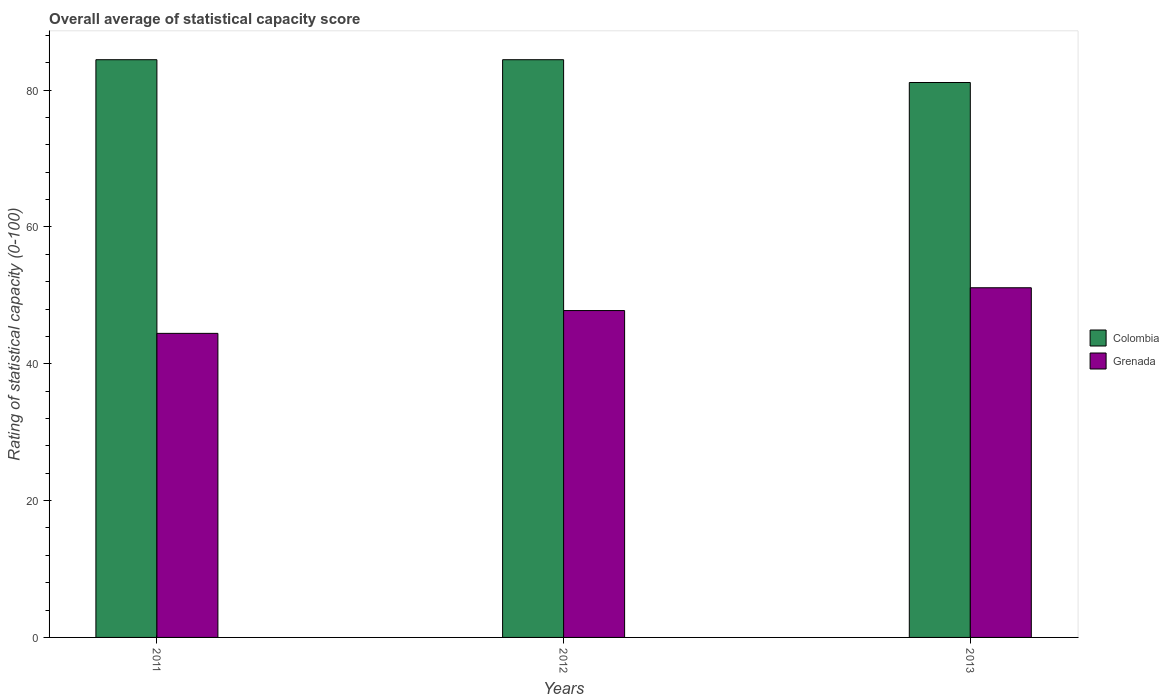How many different coloured bars are there?
Your answer should be very brief. 2. Are the number of bars on each tick of the X-axis equal?
Provide a short and direct response. Yes. How many bars are there on the 3rd tick from the right?
Make the answer very short. 2. What is the label of the 2nd group of bars from the left?
Your answer should be compact. 2012. What is the rating of statistical capacity in Colombia in 2012?
Keep it short and to the point. 84.44. Across all years, what is the maximum rating of statistical capacity in Colombia?
Keep it short and to the point. 84.44. Across all years, what is the minimum rating of statistical capacity in Colombia?
Keep it short and to the point. 81.11. In which year was the rating of statistical capacity in Colombia maximum?
Provide a short and direct response. 2011. In which year was the rating of statistical capacity in Colombia minimum?
Your answer should be compact. 2013. What is the total rating of statistical capacity in Grenada in the graph?
Your response must be concise. 143.33. What is the difference between the rating of statistical capacity in Colombia in 2011 and that in 2013?
Your response must be concise. 3.33. What is the difference between the rating of statistical capacity in Colombia in 2011 and the rating of statistical capacity in Grenada in 2012?
Your answer should be very brief. 36.67. What is the average rating of statistical capacity in Colombia per year?
Give a very brief answer. 83.33. In the year 2012, what is the difference between the rating of statistical capacity in Colombia and rating of statistical capacity in Grenada?
Your answer should be very brief. 36.67. In how many years, is the rating of statistical capacity in Grenada greater than 24?
Keep it short and to the point. 3. Is the difference between the rating of statistical capacity in Colombia in 2012 and 2013 greater than the difference between the rating of statistical capacity in Grenada in 2012 and 2013?
Provide a short and direct response. Yes. What is the difference between the highest and the lowest rating of statistical capacity in Grenada?
Keep it short and to the point. 6.67. What does the 1st bar from the left in 2013 represents?
Provide a short and direct response. Colombia. What does the 1st bar from the right in 2011 represents?
Provide a short and direct response. Grenada. Are all the bars in the graph horizontal?
Give a very brief answer. No. Are the values on the major ticks of Y-axis written in scientific E-notation?
Offer a terse response. No. Does the graph contain any zero values?
Provide a short and direct response. No. Where does the legend appear in the graph?
Your answer should be very brief. Center right. How are the legend labels stacked?
Ensure brevity in your answer.  Vertical. What is the title of the graph?
Keep it short and to the point. Overall average of statistical capacity score. What is the label or title of the Y-axis?
Your answer should be very brief. Rating of statistical capacity (0-100). What is the Rating of statistical capacity (0-100) of Colombia in 2011?
Offer a terse response. 84.44. What is the Rating of statistical capacity (0-100) of Grenada in 2011?
Offer a terse response. 44.44. What is the Rating of statistical capacity (0-100) in Colombia in 2012?
Offer a terse response. 84.44. What is the Rating of statistical capacity (0-100) of Grenada in 2012?
Your answer should be compact. 47.78. What is the Rating of statistical capacity (0-100) of Colombia in 2013?
Provide a succinct answer. 81.11. What is the Rating of statistical capacity (0-100) in Grenada in 2013?
Your response must be concise. 51.11. Across all years, what is the maximum Rating of statistical capacity (0-100) in Colombia?
Give a very brief answer. 84.44. Across all years, what is the maximum Rating of statistical capacity (0-100) in Grenada?
Give a very brief answer. 51.11. Across all years, what is the minimum Rating of statistical capacity (0-100) of Colombia?
Your answer should be very brief. 81.11. Across all years, what is the minimum Rating of statistical capacity (0-100) in Grenada?
Your answer should be compact. 44.44. What is the total Rating of statistical capacity (0-100) of Colombia in the graph?
Keep it short and to the point. 250. What is the total Rating of statistical capacity (0-100) of Grenada in the graph?
Offer a terse response. 143.33. What is the difference between the Rating of statistical capacity (0-100) of Grenada in 2011 and that in 2012?
Offer a terse response. -3.33. What is the difference between the Rating of statistical capacity (0-100) of Grenada in 2011 and that in 2013?
Give a very brief answer. -6.67. What is the difference between the Rating of statistical capacity (0-100) in Colombia in 2012 and that in 2013?
Provide a succinct answer. 3.33. What is the difference between the Rating of statistical capacity (0-100) in Grenada in 2012 and that in 2013?
Give a very brief answer. -3.33. What is the difference between the Rating of statistical capacity (0-100) in Colombia in 2011 and the Rating of statistical capacity (0-100) in Grenada in 2012?
Make the answer very short. 36.67. What is the difference between the Rating of statistical capacity (0-100) of Colombia in 2011 and the Rating of statistical capacity (0-100) of Grenada in 2013?
Your answer should be compact. 33.33. What is the difference between the Rating of statistical capacity (0-100) of Colombia in 2012 and the Rating of statistical capacity (0-100) of Grenada in 2013?
Give a very brief answer. 33.33. What is the average Rating of statistical capacity (0-100) of Colombia per year?
Make the answer very short. 83.33. What is the average Rating of statistical capacity (0-100) in Grenada per year?
Make the answer very short. 47.78. In the year 2011, what is the difference between the Rating of statistical capacity (0-100) of Colombia and Rating of statistical capacity (0-100) of Grenada?
Your answer should be very brief. 40. In the year 2012, what is the difference between the Rating of statistical capacity (0-100) of Colombia and Rating of statistical capacity (0-100) of Grenada?
Your answer should be compact. 36.67. In the year 2013, what is the difference between the Rating of statistical capacity (0-100) of Colombia and Rating of statistical capacity (0-100) of Grenada?
Offer a very short reply. 30. What is the ratio of the Rating of statistical capacity (0-100) in Grenada in 2011 to that in 2012?
Provide a short and direct response. 0.93. What is the ratio of the Rating of statistical capacity (0-100) of Colombia in 2011 to that in 2013?
Give a very brief answer. 1.04. What is the ratio of the Rating of statistical capacity (0-100) in Grenada in 2011 to that in 2013?
Provide a succinct answer. 0.87. What is the ratio of the Rating of statistical capacity (0-100) of Colombia in 2012 to that in 2013?
Give a very brief answer. 1.04. What is the ratio of the Rating of statistical capacity (0-100) of Grenada in 2012 to that in 2013?
Your response must be concise. 0.93. What is the difference between the highest and the second highest Rating of statistical capacity (0-100) in Colombia?
Your response must be concise. 0. 